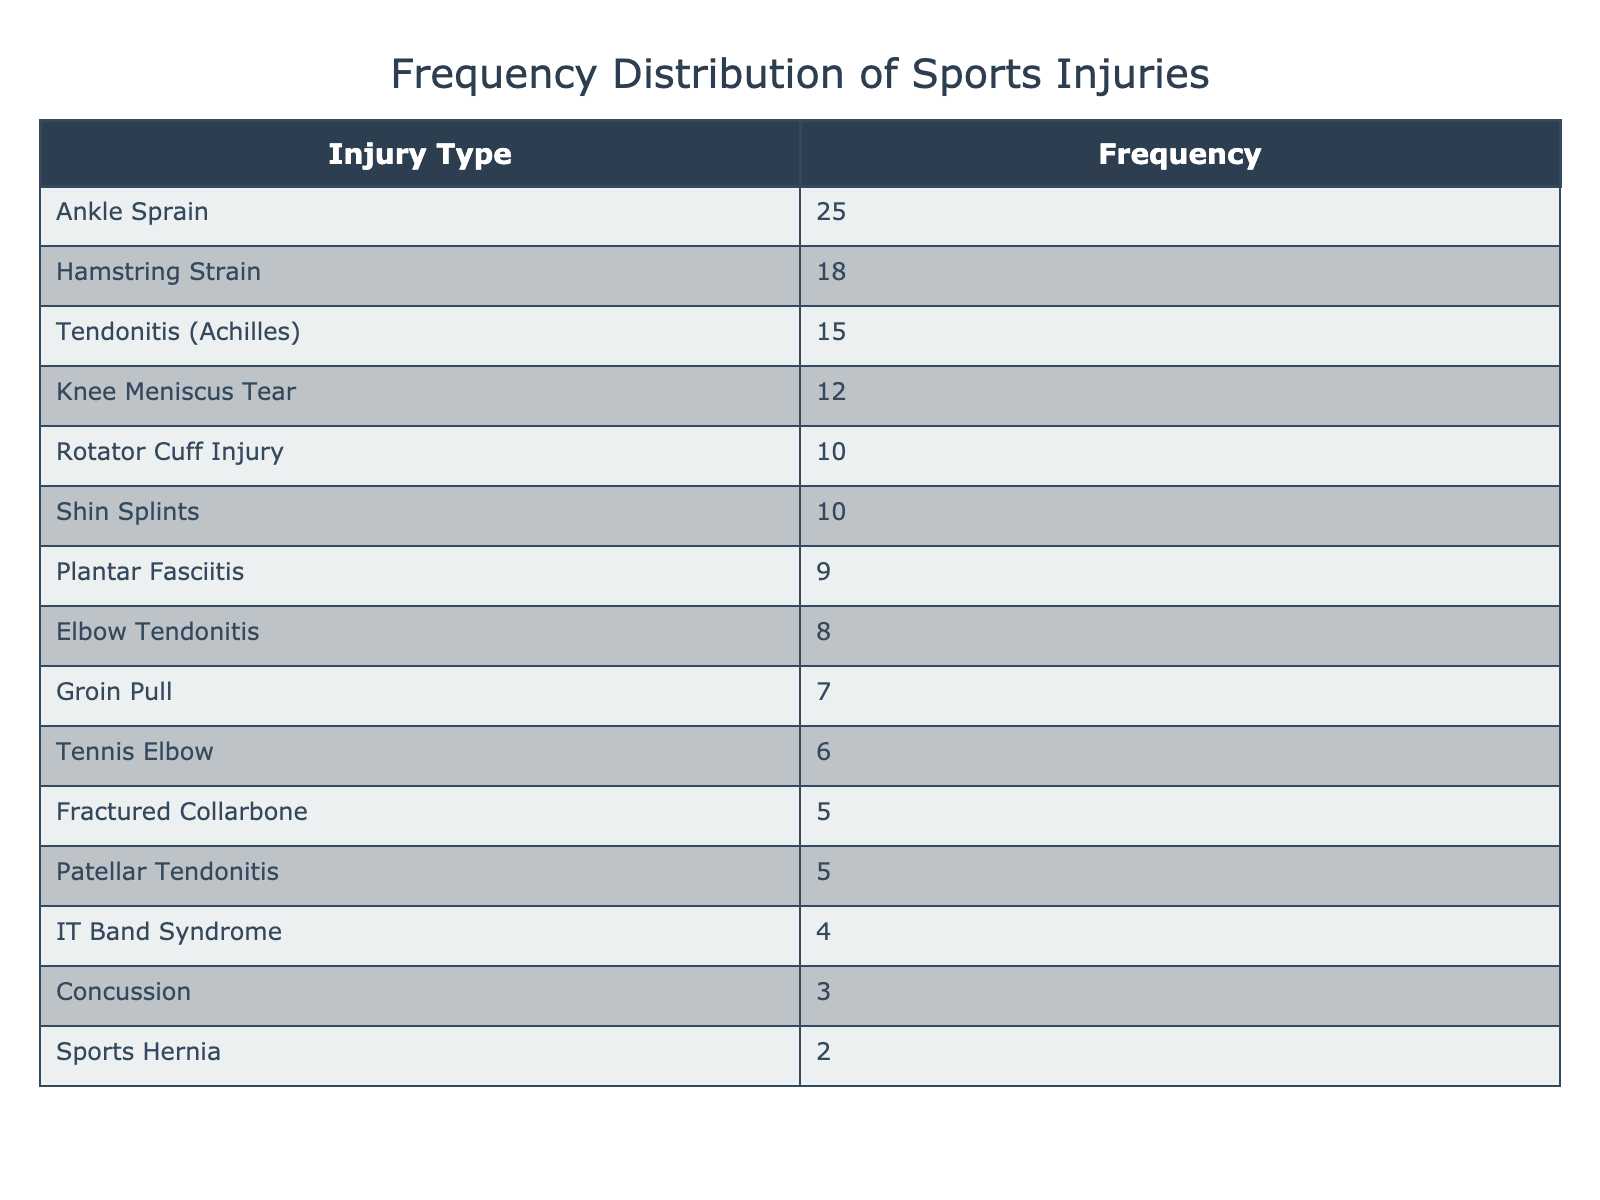What is the most common type of sports injury treated in the clinic? By looking at the table, the type of injury with the highest frequency is "Ankle Sprain," as it has the highest count of 25 in the Frequency column.
Answer: Ankle Sprain How many injuries are reported for Hamstring Strain? The table clearly shows "Hamstring Strain" with a frequency count of 18, which is the specific value asked for.
Answer: 18 What is the total frequency of injuries related to tendonitis? First, we identify all injuries related to tendonitis in the table which are "Tendonitis (Achilles)," "Elbow Tendonitis," and "Patellar Tendonitis." Summing their frequencies gives: 15 (Achilles) + 8 (Elbow) + 5 (Patellar) = 28.
Answer: 28 Is "Concussion" one of the top five most common injuries treated? By reviewing the table, we note that "Concussion" has a frequency of 3 and is not in the top five, which is determined by the five injuries with the highest frequency counts: Ankle Sprain, Hamstring Strain, Tendonitis (Achilles), Knee Meniscus Tear, and Rotator Cuff Injury.
Answer: No What is the difference in frequency between the most common and least common sports injuries? The most common injury is "Ankle Sprain" with 25 and the least common is "Sports Hernia" with 2. Therefore, the difference is calculated as 25 - 2 = 23.
Answer: 23 How many types of injuries are there with a frequency of 10 or more? The table lists injuries with the following frequencies of 10 or more: Ankle Sprain (25), Hamstring Strain (18), Tendonitis (Achilles) (15), Knee Meniscus Tear (12), Rotator Cuff Injury (10), and Shin Splints (10). This totals to six types of injuries.
Answer: 6 Which injury has a frequency count lower than 5? In the table, the injuries listed with frequencies lower than 5 are "IT Band Syndrome" (4), "Concussion" (3), and "Sports Hernia" (2). Both "IT Band Syndrome," "Concussion," and "Sports Hernia" fall into this category.
Answer: Yes What is the average frequency of the injuries listed in the table? To find the average, first, sum all frequencies: 25 + 18 + 15 + 12 + 10 + 8 + 7 + 5 + 9 + 6 + 10 + 4 + 3 + 2 + 5 =  144. Then, divide this total by the number of injury types (15): 144 / 15 = 9.6.
Answer: 9.6 